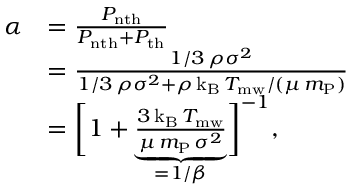Convert formula to latex. <formula><loc_0><loc_0><loc_500><loc_500>\begin{array} { r l } { \alpha } & { = \frac { P _ { n t h } } { P _ { n t h } + P _ { t h } } } \\ & { = \frac { 1 / 3 \, \rho \sigma ^ { 2 } } { 1 / 3 \, \rho \sigma ^ { 2 } + \rho \, k _ { B } \, T _ { m w } / ( \mu \, m _ { P } ) } } \\ & { = \left [ 1 + \underbrace { \frac { 3 \, k _ { B } \, T _ { m w } } { \mu \, m _ { P } \, \sigma ^ { 2 } } } _ { = 1 / \beta } \right ] ^ { - 1 } , } \end{array}</formula> 